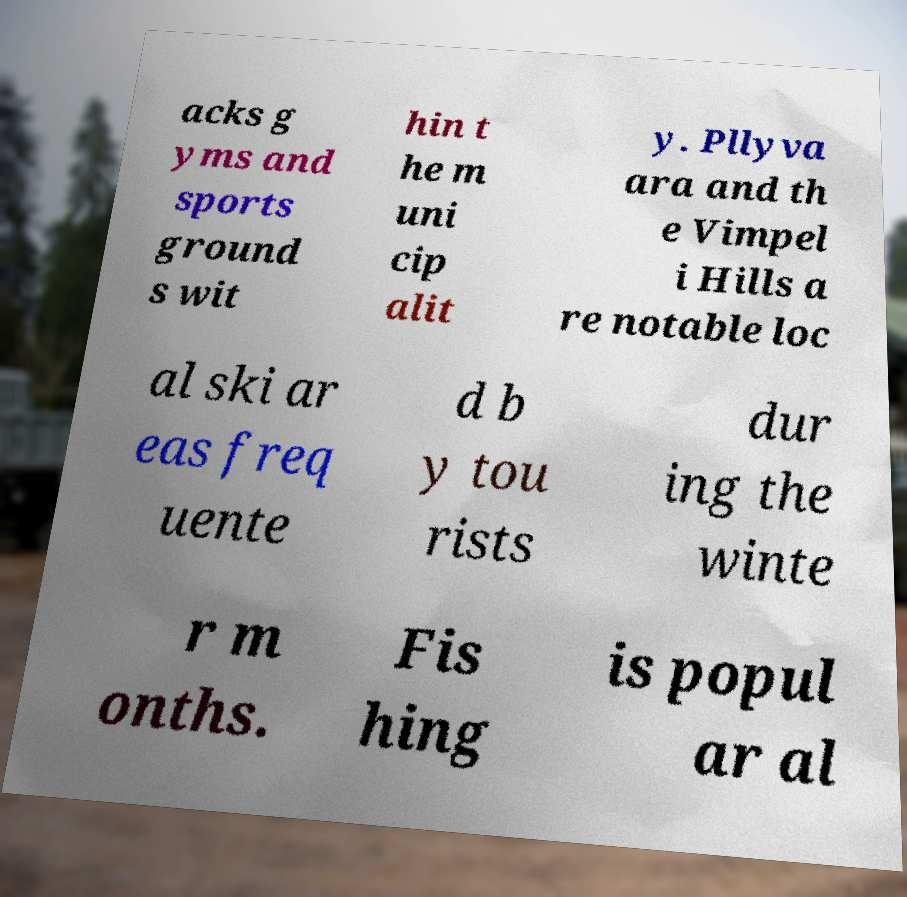What messages or text are displayed in this image? I need them in a readable, typed format. acks g yms and sports ground s wit hin t he m uni cip alit y. Pllyva ara and th e Vimpel i Hills a re notable loc al ski ar eas freq uente d b y tou rists dur ing the winte r m onths. Fis hing is popul ar al 